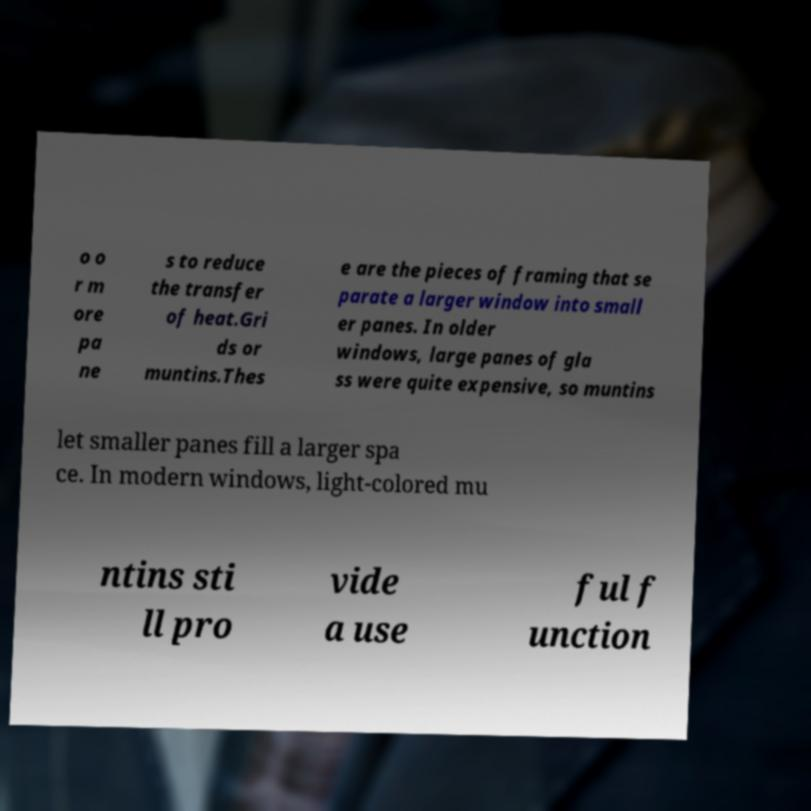What messages or text are displayed in this image? I need them in a readable, typed format. o o r m ore pa ne s to reduce the transfer of heat.Gri ds or muntins.Thes e are the pieces of framing that se parate a larger window into small er panes. In older windows, large panes of gla ss were quite expensive, so muntins let smaller panes fill a larger spa ce. In modern windows, light-colored mu ntins sti ll pro vide a use ful f unction 